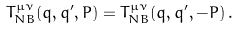Convert formula to latex. <formula><loc_0><loc_0><loc_500><loc_500>T _ { N B } ^ { \mu \nu } ( q , q ^ { \prime } , P ) = T _ { N B } ^ { \mu \nu } ( q , q ^ { \prime } , - P ) \, .</formula> 